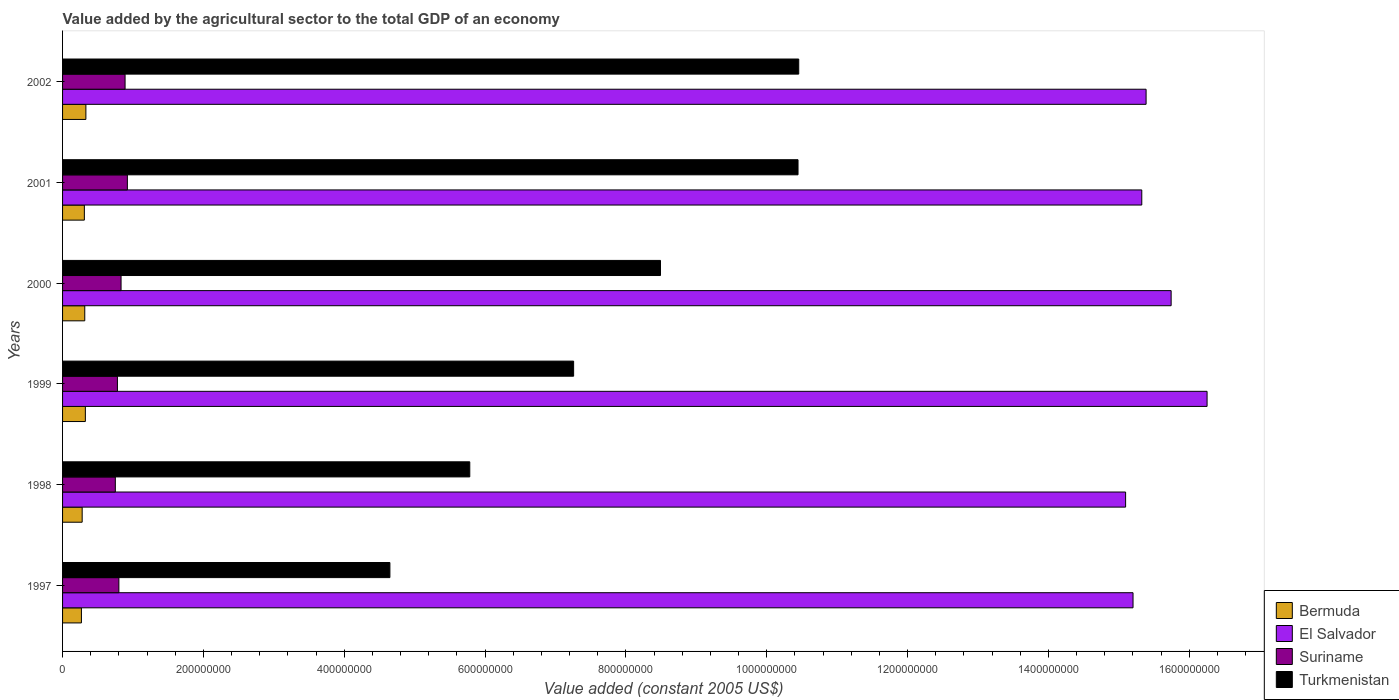How many different coloured bars are there?
Provide a succinct answer. 4. How many groups of bars are there?
Make the answer very short. 6. How many bars are there on the 5th tick from the bottom?
Your answer should be very brief. 4. What is the value added by the agricultural sector in El Salvador in 2001?
Offer a very short reply. 1.53e+09. Across all years, what is the maximum value added by the agricultural sector in El Salvador?
Make the answer very short. 1.63e+09. Across all years, what is the minimum value added by the agricultural sector in El Salvador?
Make the answer very short. 1.51e+09. In which year was the value added by the agricultural sector in Suriname minimum?
Offer a very short reply. 1998. What is the total value added by the agricultural sector in Bermuda in the graph?
Give a very brief answer. 1.83e+08. What is the difference between the value added by the agricultural sector in El Salvador in 1997 and that in 2001?
Give a very brief answer. -1.24e+07. What is the difference between the value added by the agricultural sector in Bermuda in 1997 and the value added by the agricultural sector in Turkmenistan in 2002?
Provide a short and direct response. -1.02e+09. What is the average value added by the agricultural sector in Turkmenistan per year?
Make the answer very short. 7.85e+08. In the year 1999, what is the difference between the value added by the agricultural sector in Suriname and value added by the agricultural sector in Turkmenistan?
Provide a succinct answer. -6.48e+08. In how many years, is the value added by the agricultural sector in Bermuda greater than 40000000 US$?
Your answer should be very brief. 0. What is the ratio of the value added by the agricultural sector in El Salvador in 1997 to that in 2002?
Keep it short and to the point. 0.99. Is the value added by the agricultural sector in Turkmenistan in 1997 less than that in 2000?
Make the answer very short. Yes. Is the difference between the value added by the agricultural sector in Suriname in 1997 and 1998 greater than the difference between the value added by the agricultural sector in Turkmenistan in 1997 and 1998?
Make the answer very short. Yes. What is the difference between the highest and the second highest value added by the agricultural sector in Bermuda?
Provide a short and direct response. 7.62e+05. What is the difference between the highest and the lowest value added by the agricultural sector in Bermuda?
Offer a terse response. 6.35e+06. What does the 4th bar from the top in 2001 represents?
Provide a succinct answer. Bermuda. What does the 2nd bar from the bottom in 2001 represents?
Offer a terse response. El Salvador. How many years are there in the graph?
Your answer should be very brief. 6. What is the difference between two consecutive major ticks on the X-axis?
Ensure brevity in your answer.  2.00e+08. Are the values on the major ticks of X-axis written in scientific E-notation?
Your response must be concise. No. Does the graph contain grids?
Ensure brevity in your answer.  No. How many legend labels are there?
Make the answer very short. 4. How are the legend labels stacked?
Give a very brief answer. Vertical. What is the title of the graph?
Give a very brief answer. Value added by the agricultural sector to the total GDP of an economy. What is the label or title of the X-axis?
Give a very brief answer. Value added (constant 2005 US$). What is the label or title of the Y-axis?
Give a very brief answer. Years. What is the Value added (constant 2005 US$) in Bermuda in 1997?
Your answer should be very brief. 2.68e+07. What is the Value added (constant 2005 US$) in El Salvador in 1997?
Provide a short and direct response. 1.52e+09. What is the Value added (constant 2005 US$) in Suriname in 1997?
Your answer should be compact. 8.00e+07. What is the Value added (constant 2005 US$) in Turkmenistan in 1997?
Provide a succinct answer. 4.65e+08. What is the Value added (constant 2005 US$) of Bermuda in 1998?
Ensure brevity in your answer.  2.78e+07. What is the Value added (constant 2005 US$) in El Salvador in 1998?
Your response must be concise. 1.51e+09. What is the Value added (constant 2005 US$) of Suriname in 1998?
Your answer should be compact. 7.49e+07. What is the Value added (constant 2005 US$) of Turkmenistan in 1998?
Keep it short and to the point. 5.78e+08. What is the Value added (constant 2005 US$) of Bermuda in 1999?
Give a very brief answer. 3.24e+07. What is the Value added (constant 2005 US$) in El Salvador in 1999?
Provide a short and direct response. 1.63e+09. What is the Value added (constant 2005 US$) in Suriname in 1999?
Ensure brevity in your answer.  7.79e+07. What is the Value added (constant 2005 US$) in Turkmenistan in 1999?
Provide a short and direct response. 7.26e+08. What is the Value added (constant 2005 US$) of Bermuda in 2000?
Your answer should be compact. 3.15e+07. What is the Value added (constant 2005 US$) of El Salvador in 2000?
Offer a very short reply. 1.57e+09. What is the Value added (constant 2005 US$) of Suriname in 2000?
Your answer should be very brief. 8.31e+07. What is the Value added (constant 2005 US$) of Turkmenistan in 2000?
Ensure brevity in your answer.  8.49e+08. What is the Value added (constant 2005 US$) in Bermuda in 2001?
Give a very brief answer. 3.10e+07. What is the Value added (constant 2005 US$) in El Salvador in 2001?
Provide a succinct answer. 1.53e+09. What is the Value added (constant 2005 US$) in Suriname in 2001?
Offer a very short reply. 9.20e+07. What is the Value added (constant 2005 US$) of Turkmenistan in 2001?
Your answer should be compact. 1.04e+09. What is the Value added (constant 2005 US$) of Bermuda in 2002?
Ensure brevity in your answer.  3.31e+07. What is the Value added (constant 2005 US$) of El Salvador in 2002?
Offer a terse response. 1.54e+09. What is the Value added (constant 2005 US$) of Suriname in 2002?
Your answer should be very brief. 8.88e+07. What is the Value added (constant 2005 US$) of Turkmenistan in 2002?
Offer a terse response. 1.05e+09. Across all years, what is the maximum Value added (constant 2005 US$) in Bermuda?
Keep it short and to the point. 3.31e+07. Across all years, what is the maximum Value added (constant 2005 US$) in El Salvador?
Your answer should be compact. 1.63e+09. Across all years, what is the maximum Value added (constant 2005 US$) of Suriname?
Your answer should be compact. 9.20e+07. Across all years, what is the maximum Value added (constant 2005 US$) in Turkmenistan?
Your answer should be very brief. 1.05e+09. Across all years, what is the minimum Value added (constant 2005 US$) of Bermuda?
Keep it short and to the point. 2.68e+07. Across all years, what is the minimum Value added (constant 2005 US$) in El Salvador?
Give a very brief answer. 1.51e+09. Across all years, what is the minimum Value added (constant 2005 US$) in Suriname?
Your answer should be compact. 7.49e+07. Across all years, what is the minimum Value added (constant 2005 US$) of Turkmenistan?
Offer a very short reply. 4.65e+08. What is the total Value added (constant 2005 US$) of Bermuda in the graph?
Keep it short and to the point. 1.83e+08. What is the total Value added (constant 2005 US$) in El Salvador in the graph?
Provide a short and direct response. 9.30e+09. What is the total Value added (constant 2005 US$) in Suriname in the graph?
Provide a short and direct response. 4.97e+08. What is the total Value added (constant 2005 US$) in Turkmenistan in the graph?
Your response must be concise. 4.71e+09. What is the difference between the Value added (constant 2005 US$) in Bermuda in 1997 and that in 1998?
Give a very brief answer. -1.04e+06. What is the difference between the Value added (constant 2005 US$) in El Salvador in 1997 and that in 1998?
Make the answer very short. 1.05e+07. What is the difference between the Value added (constant 2005 US$) in Suriname in 1997 and that in 1998?
Provide a succinct answer. 5.05e+06. What is the difference between the Value added (constant 2005 US$) of Turkmenistan in 1997 and that in 1998?
Give a very brief answer. -1.13e+08. What is the difference between the Value added (constant 2005 US$) in Bermuda in 1997 and that in 1999?
Make the answer very short. -5.58e+06. What is the difference between the Value added (constant 2005 US$) in El Salvador in 1997 and that in 1999?
Your response must be concise. -1.05e+08. What is the difference between the Value added (constant 2005 US$) of Suriname in 1997 and that in 1999?
Your response must be concise. 2.06e+06. What is the difference between the Value added (constant 2005 US$) in Turkmenistan in 1997 and that in 1999?
Your answer should be very brief. -2.61e+08. What is the difference between the Value added (constant 2005 US$) in Bermuda in 1997 and that in 2000?
Make the answer very short. -4.74e+06. What is the difference between the Value added (constant 2005 US$) of El Salvador in 1997 and that in 2000?
Provide a succinct answer. -5.41e+07. What is the difference between the Value added (constant 2005 US$) in Suriname in 1997 and that in 2000?
Your response must be concise. -3.09e+06. What is the difference between the Value added (constant 2005 US$) of Turkmenistan in 1997 and that in 2000?
Provide a succinct answer. -3.84e+08. What is the difference between the Value added (constant 2005 US$) of Bermuda in 1997 and that in 2001?
Offer a very short reply. -4.17e+06. What is the difference between the Value added (constant 2005 US$) of El Salvador in 1997 and that in 2001?
Your answer should be compact. -1.24e+07. What is the difference between the Value added (constant 2005 US$) of Suriname in 1997 and that in 2001?
Your answer should be compact. -1.21e+07. What is the difference between the Value added (constant 2005 US$) in Turkmenistan in 1997 and that in 2001?
Give a very brief answer. -5.80e+08. What is the difference between the Value added (constant 2005 US$) in Bermuda in 1997 and that in 2002?
Your answer should be very brief. -6.35e+06. What is the difference between the Value added (constant 2005 US$) in El Salvador in 1997 and that in 2002?
Provide a succinct answer. -1.85e+07. What is the difference between the Value added (constant 2005 US$) of Suriname in 1997 and that in 2002?
Give a very brief answer. -8.80e+06. What is the difference between the Value added (constant 2005 US$) of Turkmenistan in 1997 and that in 2002?
Make the answer very short. -5.81e+08. What is the difference between the Value added (constant 2005 US$) of Bermuda in 1998 and that in 1999?
Your answer should be compact. -4.54e+06. What is the difference between the Value added (constant 2005 US$) in El Salvador in 1998 and that in 1999?
Keep it short and to the point. -1.16e+08. What is the difference between the Value added (constant 2005 US$) in Suriname in 1998 and that in 1999?
Keep it short and to the point. -2.99e+06. What is the difference between the Value added (constant 2005 US$) in Turkmenistan in 1998 and that in 1999?
Provide a short and direct response. -1.47e+08. What is the difference between the Value added (constant 2005 US$) of Bermuda in 1998 and that in 2000?
Provide a short and direct response. -3.70e+06. What is the difference between the Value added (constant 2005 US$) in El Salvador in 1998 and that in 2000?
Keep it short and to the point. -6.47e+07. What is the difference between the Value added (constant 2005 US$) of Suriname in 1998 and that in 2000?
Offer a terse response. -8.14e+06. What is the difference between the Value added (constant 2005 US$) of Turkmenistan in 1998 and that in 2000?
Provide a succinct answer. -2.71e+08. What is the difference between the Value added (constant 2005 US$) of Bermuda in 1998 and that in 2001?
Make the answer very short. -3.12e+06. What is the difference between the Value added (constant 2005 US$) in El Salvador in 1998 and that in 2001?
Your response must be concise. -2.30e+07. What is the difference between the Value added (constant 2005 US$) of Suriname in 1998 and that in 2001?
Offer a terse response. -1.71e+07. What is the difference between the Value added (constant 2005 US$) in Turkmenistan in 1998 and that in 2001?
Your answer should be very brief. -4.66e+08. What is the difference between the Value added (constant 2005 US$) of Bermuda in 1998 and that in 2002?
Give a very brief answer. -5.30e+06. What is the difference between the Value added (constant 2005 US$) of El Salvador in 1998 and that in 2002?
Give a very brief answer. -2.91e+07. What is the difference between the Value added (constant 2005 US$) in Suriname in 1998 and that in 2002?
Make the answer very short. -1.38e+07. What is the difference between the Value added (constant 2005 US$) in Turkmenistan in 1998 and that in 2002?
Your answer should be very brief. -4.67e+08. What is the difference between the Value added (constant 2005 US$) of Bermuda in 1999 and that in 2000?
Your answer should be compact. 8.38e+05. What is the difference between the Value added (constant 2005 US$) of El Salvador in 1999 and that in 2000?
Keep it short and to the point. 5.10e+07. What is the difference between the Value added (constant 2005 US$) of Suriname in 1999 and that in 2000?
Provide a succinct answer. -5.16e+06. What is the difference between the Value added (constant 2005 US$) in Turkmenistan in 1999 and that in 2000?
Provide a short and direct response. -1.23e+08. What is the difference between the Value added (constant 2005 US$) of Bermuda in 1999 and that in 2001?
Make the answer very short. 1.42e+06. What is the difference between the Value added (constant 2005 US$) in El Salvador in 1999 and that in 2001?
Your response must be concise. 9.27e+07. What is the difference between the Value added (constant 2005 US$) in Suriname in 1999 and that in 2001?
Your response must be concise. -1.41e+07. What is the difference between the Value added (constant 2005 US$) of Turkmenistan in 1999 and that in 2001?
Provide a short and direct response. -3.19e+08. What is the difference between the Value added (constant 2005 US$) of Bermuda in 1999 and that in 2002?
Provide a short and direct response. -7.62e+05. What is the difference between the Value added (constant 2005 US$) of El Salvador in 1999 and that in 2002?
Make the answer very short. 8.66e+07. What is the difference between the Value added (constant 2005 US$) in Suriname in 1999 and that in 2002?
Offer a very short reply. -1.09e+07. What is the difference between the Value added (constant 2005 US$) of Turkmenistan in 1999 and that in 2002?
Offer a very short reply. -3.20e+08. What is the difference between the Value added (constant 2005 US$) in Bermuda in 2000 and that in 2001?
Give a very brief answer. 5.77e+05. What is the difference between the Value added (constant 2005 US$) of El Salvador in 2000 and that in 2001?
Your answer should be very brief. 4.17e+07. What is the difference between the Value added (constant 2005 US$) in Suriname in 2000 and that in 2001?
Make the answer very short. -8.96e+06. What is the difference between the Value added (constant 2005 US$) of Turkmenistan in 2000 and that in 2001?
Keep it short and to the point. -1.95e+08. What is the difference between the Value added (constant 2005 US$) of Bermuda in 2000 and that in 2002?
Offer a very short reply. -1.60e+06. What is the difference between the Value added (constant 2005 US$) in El Salvador in 2000 and that in 2002?
Provide a succinct answer. 3.56e+07. What is the difference between the Value added (constant 2005 US$) in Suriname in 2000 and that in 2002?
Provide a succinct answer. -5.70e+06. What is the difference between the Value added (constant 2005 US$) of Turkmenistan in 2000 and that in 2002?
Your response must be concise. -1.96e+08. What is the difference between the Value added (constant 2005 US$) in Bermuda in 2001 and that in 2002?
Provide a succinct answer. -2.18e+06. What is the difference between the Value added (constant 2005 US$) of El Salvador in 2001 and that in 2002?
Your answer should be very brief. -6.12e+06. What is the difference between the Value added (constant 2005 US$) of Suriname in 2001 and that in 2002?
Your response must be concise. 3.26e+06. What is the difference between the Value added (constant 2005 US$) in Turkmenistan in 2001 and that in 2002?
Provide a short and direct response. -9.92e+05. What is the difference between the Value added (constant 2005 US$) of Bermuda in 1997 and the Value added (constant 2005 US$) of El Salvador in 1998?
Your answer should be very brief. -1.48e+09. What is the difference between the Value added (constant 2005 US$) in Bermuda in 1997 and the Value added (constant 2005 US$) in Suriname in 1998?
Your response must be concise. -4.81e+07. What is the difference between the Value added (constant 2005 US$) in Bermuda in 1997 and the Value added (constant 2005 US$) in Turkmenistan in 1998?
Ensure brevity in your answer.  -5.51e+08. What is the difference between the Value added (constant 2005 US$) of El Salvador in 1997 and the Value added (constant 2005 US$) of Suriname in 1998?
Keep it short and to the point. 1.45e+09. What is the difference between the Value added (constant 2005 US$) in El Salvador in 1997 and the Value added (constant 2005 US$) in Turkmenistan in 1998?
Offer a terse response. 9.42e+08. What is the difference between the Value added (constant 2005 US$) of Suriname in 1997 and the Value added (constant 2005 US$) of Turkmenistan in 1998?
Ensure brevity in your answer.  -4.98e+08. What is the difference between the Value added (constant 2005 US$) of Bermuda in 1997 and the Value added (constant 2005 US$) of El Salvador in 1999?
Your answer should be compact. -1.60e+09. What is the difference between the Value added (constant 2005 US$) of Bermuda in 1997 and the Value added (constant 2005 US$) of Suriname in 1999?
Provide a succinct answer. -5.11e+07. What is the difference between the Value added (constant 2005 US$) in Bermuda in 1997 and the Value added (constant 2005 US$) in Turkmenistan in 1999?
Offer a terse response. -6.99e+08. What is the difference between the Value added (constant 2005 US$) of El Salvador in 1997 and the Value added (constant 2005 US$) of Suriname in 1999?
Provide a succinct answer. 1.44e+09. What is the difference between the Value added (constant 2005 US$) of El Salvador in 1997 and the Value added (constant 2005 US$) of Turkmenistan in 1999?
Offer a terse response. 7.94e+08. What is the difference between the Value added (constant 2005 US$) of Suriname in 1997 and the Value added (constant 2005 US$) of Turkmenistan in 1999?
Your answer should be very brief. -6.46e+08. What is the difference between the Value added (constant 2005 US$) in Bermuda in 1997 and the Value added (constant 2005 US$) in El Salvador in 2000?
Make the answer very short. -1.55e+09. What is the difference between the Value added (constant 2005 US$) in Bermuda in 1997 and the Value added (constant 2005 US$) in Suriname in 2000?
Give a very brief answer. -5.63e+07. What is the difference between the Value added (constant 2005 US$) of Bermuda in 1997 and the Value added (constant 2005 US$) of Turkmenistan in 2000?
Keep it short and to the point. -8.22e+08. What is the difference between the Value added (constant 2005 US$) in El Salvador in 1997 and the Value added (constant 2005 US$) in Suriname in 2000?
Make the answer very short. 1.44e+09. What is the difference between the Value added (constant 2005 US$) in El Salvador in 1997 and the Value added (constant 2005 US$) in Turkmenistan in 2000?
Keep it short and to the point. 6.71e+08. What is the difference between the Value added (constant 2005 US$) of Suriname in 1997 and the Value added (constant 2005 US$) of Turkmenistan in 2000?
Provide a short and direct response. -7.69e+08. What is the difference between the Value added (constant 2005 US$) in Bermuda in 1997 and the Value added (constant 2005 US$) in El Salvador in 2001?
Give a very brief answer. -1.51e+09. What is the difference between the Value added (constant 2005 US$) of Bermuda in 1997 and the Value added (constant 2005 US$) of Suriname in 2001?
Offer a very short reply. -6.52e+07. What is the difference between the Value added (constant 2005 US$) in Bermuda in 1997 and the Value added (constant 2005 US$) in Turkmenistan in 2001?
Your response must be concise. -1.02e+09. What is the difference between the Value added (constant 2005 US$) in El Salvador in 1997 and the Value added (constant 2005 US$) in Suriname in 2001?
Your answer should be very brief. 1.43e+09. What is the difference between the Value added (constant 2005 US$) in El Salvador in 1997 and the Value added (constant 2005 US$) in Turkmenistan in 2001?
Give a very brief answer. 4.76e+08. What is the difference between the Value added (constant 2005 US$) of Suriname in 1997 and the Value added (constant 2005 US$) of Turkmenistan in 2001?
Your answer should be very brief. -9.64e+08. What is the difference between the Value added (constant 2005 US$) of Bermuda in 1997 and the Value added (constant 2005 US$) of El Salvador in 2002?
Ensure brevity in your answer.  -1.51e+09. What is the difference between the Value added (constant 2005 US$) in Bermuda in 1997 and the Value added (constant 2005 US$) in Suriname in 2002?
Provide a short and direct response. -6.20e+07. What is the difference between the Value added (constant 2005 US$) in Bermuda in 1997 and the Value added (constant 2005 US$) in Turkmenistan in 2002?
Provide a short and direct response. -1.02e+09. What is the difference between the Value added (constant 2005 US$) in El Salvador in 1997 and the Value added (constant 2005 US$) in Suriname in 2002?
Provide a short and direct response. 1.43e+09. What is the difference between the Value added (constant 2005 US$) in El Salvador in 1997 and the Value added (constant 2005 US$) in Turkmenistan in 2002?
Offer a terse response. 4.75e+08. What is the difference between the Value added (constant 2005 US$) in Suriname in 1997 and the Value added (constant 2005 US$) in Turkmenistan in 2002?
Make the answer very short. -9.65e+08. What is the difference between the Value added (constant 2005 US$) of Bermuda in 1998 and the Value added (constant 2005 US$) of El Salvador in 1999?
Offer a very short reply. -1.60e+09. What is the difference between the Value added (constant 2005 US$) in Bermuda in 1998 and the Value added (constant 2005 US$) in Suriname in 1999?
Offer a very short reply. -5.01e+07. What is the difference between the Value added (constant 2005 US$) in Bermuda in 1998 and the Value added (constant 2005 US$) in Turkmenistan in 1999?
Provide a short and direct response. -6.98e+08. What is the difference between the Value added (constant 2005 US$) of El Salvador in 1998 and the Value added (constant 2005 US$) of Suriname in 1999?
Offer a terse response. 1.43e+09. What is the difference between the Value added (constant 2005 US$) of El Salvador in 1998 and the Value added (constant 2005 US$) of Turkmenistan in 1999?
Give a very brief answer. 7.84e+08. What is the difference between the Value added (constant 2005 US$) of Suriname in 1998 and the Value added (constant 2005 US$) of Turkmenistan in 1999?
Your response must be concise. -6.51e+08. What is the difference between the Value added (constant 2005 US$) in Bermuda in 1998 and the Value added (constant 2005 US$) in El Salvador in 2000?
Offer a terse response. -1.55e+09. What is the difference between the Value added (constant 2005 US$) of Bermuda in 1998 and the Value added (constant 2005 US$) of Suriname in 2000?
Give a very brief answer. -5.52e+07. What is the difference between the Value added (constant 2005 US$) of Bermuda in 1998 and the Value added (constant 2005 US$) of Turkmenistan in 2000?
Offer a terse response. -8.21e+08. What is the difference between the Value added (constant 2005 US$) of El Salvador in 1998 and the Value added (constant 2005 US$) of Suriname in 2000?
Your response must be concise. 1.43e+09. What is the difference between the Value added (constant 2005 US$) in El Salvador in 1998 and the Value added (constant 2005 US$) in Turkmenistan in 2000?
Give a very brief answer. 6.60e+08. What is the difference between the Value added (constant 2005 US$) of Suriname in 1998 and the Value added (constant 2005 US$) of Turkmenistan in 2000?
Your response must be concise. -7.74e+08. What is the difference between the Value added (constant 2005 US$) in Bermuda in 1998 and the Value added (constant 2005 US$) in El Salvador in 2001?
Your answer should be compact. -1.50e+09. What is the difference between the Value added (constant 2005 US$) of Bermuda in 1998 and the Value added (constant 2005 US$) of Suriname in 2001?
Ensure brevity in your answer.  -6.42e+07. What is the difference between the Value added (constant 2005 US$) of Bermuda in 1998 and the Value added (constant 2005 US$) of Turkmenistan in 2001?
Your response must be concise. -1.02e+09. What is the difference between the Value added (constant 2005 US$) in El Salvador in 1998 and the Value added (constant 2005 US$) in Suriname in 2001?
Ensure brevity in your answer.  1.42e+09. What is the difference between the Value added (constant 2005 US$) of El Salvador in 1998 and the Value added (constant 2005 US$) of Turkmenistan in 2001?
Ensure brevity in your answer.  4.65e+08. What is the difference between the Value added (constant 2005 US$) in Suriname in 1998 and the Value added (constant 2005 US$) in Turkmenistan in 2001?
Ensure brevity in your answer.  -9.69e+08. What is the difference between the Value added (constant 2005 US$) in Bermuda in 1998 and the Value added (constant 2005 US$) in El Salvador in 2002?
Make the answer very short. -1.51e+09. What is the difference between the Value added (constant 2005 US$) in Bermuda in 1998 and the Value added (constant 2005 US$) in Suriname in 2002?
Your answer should be very brief. -6.09e+07. What is the difference between the Value added (constant 2005 US$) in Bermuda in 1998 and the Value added (constant 2005 US$) in Turkmenistan in 2002?
Give a very brief answer. -1.02e+09. What is the difference between the Value added (constant 2005 US$) of El Salvador in 1998 and the Value added (constant 2005 US$) of Suriname in 2002?
Make the answer very short. 1.42e+09. What is the difference between the Value added (constant 2005 US$) in El Salvador in 1998 and the Value added (constant 2005 US$) in Turkmenistan in 2002?
Give a very brief answer. 4.64e+08. What is the difference between the Value added (constant 2005 US$) of Suriname in 1998 and the Value added (constant 2005 US$) of Turkmenistan in 2002?
Offer a terse response. -9.70e+08. What is the difference between the Value added (constant 2005 US$) of Bermuda in 1999 and the Value added (constant 2005 US$) of El Salvador in 2000?
Keep it short and to the point. -1.54e+09. What is the difference between the Value added (constant 2005 US$) of Bermuda in 1999 and the Value added (constant 2005 US$) of Suriname in 2000?
Your answer should be very brief. -5.07e+07. What is the difference between the Value added (constant 2005 US$) in Bermuda in 1999 and the Value added (constant 2005 US$) in Turkmenistan in 2000?
Keep it short and to the point. -8.17e+08. What is the difference between the Value added (constant 2005 US$) in El Salvador in 1999 and the Value added (constant 2005 US$) in Suriname in 2000?
Offer a very short reply. 1.54e+09. What is the difference between the Value added (constant 2005 US$) in El Salvador in 1999 and the Value added (constant 2005 US$) in Turkmenistan in 2000?
Make the answer very short. 7.76e+08. What is the difference between the Value added (constant 2005 US$) in Suriname in 1999 and the Value added (constant 2005 US$) in Turkmenistan in 2000?
Make the answer very short. -7.71e+08. What is the difference between the Value added (constant 2005 US$) of Bermuda in 1999 and the Value added (constant 2005 US$) of El Salvador in 2001?
Provide a short and direct response. -1.50e+09. What is the difference between the Value added (constant 2005 US$) of Bermuda in 1999 and the Value added (constant 2005 US$) of Suriname in 2001?
Your answer should be compact. -5.97e+07. What is the difference between the Value added (constant 2005 US$) in Bermuda in 1999 and the Value added (constant 2005 US$) in Turkmenistan in 2001?
Your response must be concise. -1.01e+09. What is the difference between the Value added (constant 2005 US$) of El Salvador in 1999 and the Value added (constant 2005 US$) of Suriname in 2001?
Keep it short and to the point. 1.53e+09. What is the difference between the Value added (constant 2005 US$) in El Salvador in 1999 and the Value added (constant 2005 US$) in Turkmenistan in 2001?
Make the answer very short. 5.81e+08. What is the difference between the Value added (constant 2005 US$) of Suriname in 1999 and the Value added (constant 2005 US$) of Turkmenistan in 2001?
Offer a very short reply. -9.66e+08. What is the difference between the Value added (constant 2005 US$) of Bermuda in 1999 and the Value added (constant 2005 US$) of El Salvador in 2002?
Provide a succinct answer. -1.51e+09. What is the difference between the Value added (constant 2005 US$) of Bermuda in 1999 and the Value added (constant 2005 US$) of Suriname in 2002?
Your answer should be compact. -5.64e+07. What is the difference between the Value added (constant 2005 US$) of Bermuda in 1999 and the Value added (constant 2005 US$) of Turkmenistan in 2002?
Give a very brief answer. -1.01e+09. What is the difference between the Value added (constant 2005 US$) in El Salvador in 1999 and the Value added (constant 2005 US$) in Suriname in 2002?
Provide a short and direct response. 1.54e+09. What is the difference between the Value added (constant 2005 US$) in El Salvador in 1999 and the Value added (constant 2005 US$) in Turkmenistan in 2002?
Ensure brevity in your answer.  5.80e+08. What is the difference between the Value added (constant 2005 US$) of Suriname in 1999 and the Value added (constant 2005 US$) of Turkmenistan in 2002?
Make the answer very short. -9.67e+08. What is the difference between the Value added (constant 2005 US$) in Bermuda in 2000 and the Value added (constant 2005 US$) in El Salvador in 2001?
Your answer should be compact. -1.50e+09. What is the difference between the Value added (constant 2005 US$) in Bermuda in 2000 and the Value added (constant 2005 US$) in Suriname in 2001?
Offer a terse response. -6.05e+07. What is the difference between the Value added (constant 2005 US$) in Bermuda in 2000 and the Value added (constant 2005 US$) in Turkmenistan in 2001?
Provide a succinct answer. -1.01e+09. What is the difference between the Value added (constant 2005 US$) in El Salvador in 2000 and the Value added (constant 2005 US$) in Suriname in 2001?
Your answer should be very brief. 1.48e+09. What is the difference between the Value added (constant 2005 US$) in El Salvador in 2000 and the Value added (constant 2005 US$) in Turkmenistan in 2001?
Ensure brevity in your answer.  5.30e+08. What is the difference between the Value added (constant 2005 US$) of Suriname in 2000 and the Value added (constant 2005 US$) of Turkmenistan in 2001?
Make the answer very short. -9.61e+08. What is the difference between the Value added (constant 2005 US$) in Bermuda in 2000 and the Value added (constant 2005 US$) in El Salvador in 2002?
Offer a very short reply. -1.51e+09. What is the difference between the Value added (constant 2005 US$) of Bermuda in 2000 and the Value added (constant 2005 US$) of Suriname in 2002?
Provide a succinct answer. -5.72e+07. What is the difference between the Value added (constant 2005 US$) in Bermuda in 2000 and the Value added (constant 2005 US$) in Turkmenistan in 2002?
Your answer should be very brief. -1.01e+09. What is the difference between the Value added (constant 2005 US$) of El Salvador in 2000 and the Value added (constant 2005 US$) of Suriname in 2002?
Keep it short and to the point. 1.49e+09. What is the difference between the Value added (constant 2005 US$) in El Salvador in 2000 and the Value added (constant 2005 US$) in Turkmenistan in 2002?
Your answer should be very brief. 5.29e+08. What is the difference between the Value added (constant 2005 US$) in Suriname in 2000 and the Value added (constant 2005 US$) in Turkmenistan in 2002?
Make the answer very short. -9.62e+08. What is the difference between the Value added (constant 2005 US$) of Bermuda in 2001 and the Value added (constant 2005 US$) of El Salvador in 2002?
Your answer should be very brief. -1.51e+09. What is the difference between the Value added (constant 2005 US$) in Bermuda in 2001 and the Value added (constant 2005 US$) in Suriname in 2002?
Give a very brief answer. -5.78e+07. What is the difference between the Value added (constant 2005 US$) in Bermuda in 2001 and the Value added (constant 2005 US$) in Turkmenistan in 2002?
Give a very brief answer. -1.01e+09. What is the difference between the Value added (constant 2005 US$) in El Salvador in 2001 and the Value added (constant 2005 US$) in Suriname in 2002?
Make the answer very short. 1.44e+09. What is the difference between the Value added (constant 2005 US$) in El Salvador in 2001 and the Value added (constant 2005 US$) in Turkmenistan in 2002?
Offer a very short reply. 4.87e+08. What is the difference between the Value added (constant 2005 US$) of Suriname in 2001 and the Value added (constant 2005 US$) of Turkmenistan in 2002?
Offer a terse response. -9.53e+08. What is the average Value added (constant 2005 US$) of Bermuda per year?
Offer a very short reply. 3.04e+07. What is the average Value added (constant 2005 US$) of El Salvador per year?
Offer a very short reply. 1.55e+09. What is the average Value added (constant 2005 US$) in Suriname per year?
Provide a short and direct response. 8.28e+07. What is the average Value added (constant 2005 US$) in Turkmenistan per year?
Provide a short and direct response. 7.85e+08. In the year 1997, what is the difference between the Value added (constant 2005 US$) of Bermuda and Value added (constant 2005 US$) of El Salvador?
Provide a short and direct response. -1.49e+09. In the year 1997, what is the difference between the Value added (constant 2005 US$) in Bermuda and Value added (constant 2005 US$) in Suriname?
Provide a short and direct response. -5.32e+07. In the year 1997, what is the difference between the Value added (constant 2005 US$) of Bermuda and Value added (constant 2005 US$) of Turkmenistan?
Your answer should be very brief. -4.38e+08. In the year 1997, what is the difference between the Value added (constant 2005 US$) in El Salvador and Value added (constant 2005 US$) in Suriname?
Your answer should be very brief. 1.44e+09. In the year 1997, what is the difference between the Value added (constant 2005 US$) in El Salvador and Value added (constant 2005 US$) in Turkmenistan?
Keep it short and to the point. 1.06e+09. In the year 1997, what is the difference between the Value added (constant 2005 US$) in Suriname and Value added (constant 2005 US$) in Turkmenistan?
Your response must be concise. -3.85e+08. In the year 1998, what is the difference between the Value added (constant 2005 US$) in Bermuda and Value added (constant 2005 US$) in El Salvador?
Offer a very short reply. -1.48e+09. In the year 1998, what is the difference between the Value added (constant 2005 US$) in Bermuda and Value added (constant 2005 US$) in Suriname?
Keep it short and to the point. -4.71e+07. In the year 1998, what is the difference between the Value added (constant 2005 US$) of Bermuda and Value added (constant 2005 US$) of Turkmenistan?
Provide a succinct answer. -5.50e+08. In the year 1998, what is the difference between the Value added (constant 2005 US$) in El Salvador and Value added (constant 2005 US$) in Suriname?
Keep it short and to the point. 1.43e+09. In the year 1998, what is the difference between the Value added (constant 2005 US$) of El Salvador and Value added (constant 2005 US$) of Turkmenistan?
Your answer should be compact. 9.31e+08. In the year 1998, what is the difference between the Value added (constant 2005 US$) in Suriname and Value added (constant 2005 US$) in Turkmenistan?
Give a very brief answer. -5.03e+08. In the year 1999, what is the difference between the Value added (constant 2005 US$) of Bermuda and Value added (constant 2005 US$) of El Salvador?
Your answer should be compact. -1.59e+09. In the year 1999, what is the difference between the Value added (constant 2005 US$) in Bermuda and Value added (constant 2005 US$) in Suriname?
Your answer should be very brief. -4.55e+07. In the year 1999, what is the difference between the Value added (constant 2005 US$) of Bermuda and Value added (constant 2005 US$) of Turkmenistan?
Provide a short and direct response. -6.93e+08. In the year 1999, what is the difference between the Value added (constant 2005 US$) of El Salvador and Value added (constant 2005 US$) of Suriname?
Ensure brevity in your answer.  1.55e+09. In the year 1999, what is the difference between the Value added (constant 2005 US$) of El Salvador and Value added (constant 2005 US$) of Turkmenistan?
Provide a short and direct response. 9.00e+08. In the year 1999, what is the difference between the Value added (constant 2005 US$) in Suriname and Value added (constant 2005 US$) in Turkmenistan?
Provide a succinct answer. -6.48e+08. In the year 2000, what is the difference between the Value added (constant 2005 US$) in Bermuda and Value added (constant 2005 US$) in El Salvador?
Your answer should be compact. -1.54e+09. In the year 2000, what is the difference between the Value added (constant 2005 US$) of Bermuda and Value added (constant 2005 US$) of Suriname?
Give a very brief answer. -5.15e+07. In the year 2000, what is the difference between the Value added (constant 2005 US$) of Bermuda and Value added (constant 2005 US$) of Turkmenistan?
Offer a terse response. -8.18e+08. In the year 2000, what is the difference between the Value added (constant 2005 US$) in El Salvador and Value added (constant 2005 US$) in Suriname?
Make the answer very short. 1.49e+09. In the year 2000, what is the difference between the Value added (constant 2005 US$) of El Salvador and Value added (constant 2005 US$) of Turkmenistan?
Offer a terse response. 7.25e+08. In the year 2000, what is the difference between the Value added (constant 2005 US$) in Suriname and Value added (constant 2005 US$) in Turkmenistan?
Offer a very short reply. -7.66e+08. In the year 2001, what is the difference between the Value added (constant 2005 US$) in Bermuda and Value added (constant 2005 US$) in El Salvador?
Offer a terse response. -1.50e+09. In the year 2001, what is the difference between the Value added (constant 2005 US$) in Bermuda and Value added (constant 2005 US$) in Suriname?
Your answer should be compact. -6.11e+07. In the year 2001, what is the difference between the Value added (constant 2005 US$) in Bermuda and Value added (constant 2005 US$) in Turkmenistan?
Give a very brief answer. -1.01e+09. In the year 2001, what is the difference between the Value added (constant 2005 US$) of El Salvador and Value added (constant 2005 US$) of Suriname?
Your response must be concise. 1.44e+09. In the year 2001, what is the difference between the Value added (constant 2005 US$) of El Salvador and Value added (constant 2005 US$) of Turkmenistan?
Provide a short and direct response. 4.88e+08. In the year 2001, what is the difference between the Value added (constant 2005 US$) of Suriname and Value added (constant 2005 US$) of Turkmenistan?
Offer a very short reply. -9.52e+08. In the year 2002, what is the difference between the Value added (constant 2005 US$) of Bermuda and Value added (constant 2005 US$) of El Salvador?
Your response must be concise. -1.51e+09. In the year 2002, what is the difference between the Value added (constant 2005 US$) of Bermuda and Value added (constant 2005 US$) of Suriname?
Make the answer very short. -5.56e+07. In the year 2002, what is the difference between the Value added (constant 2005 US$) in Bermuda and Value added (constant 2005 US$) in Turkmenistan?
Your answer should be compact. -1.01e+09. In the year 2002, what is the difference between the Value added (constant 2005 US$) of El Salvador and Value added (constant 2005 US$) of Suriname?
Make the answer very short. 1.45e+09. In the year 2002, what is the difference between the Value added (constant 2005 US$) of El Salvador and Value added (constant 2005 US$) of Turkmenistan?
Offer a terse response. 4.93e+08. In the year 2002, what is the difference between the Value added (constant 2005 US$) in Suriname and Value added (constant 2005 US$) in Turkmenistan?
Give a very brief answer. -9.57e+08. What is the ratio of the Value added (constant 2005 US$) in Bermuda in 1997 to that in 1998?
Offer a very short reply. 0.96. What is the ratio of the Value added (constant 2005 US$) in El Salvador in 1997 to that in 1998?
Give a very brief answer. 1.01. What is the ratio of the Value added (constant 2005 US$) in Suriname in 1997 to that in 1998?
Offer a terse response. 1.07. What is the ratio of the Value added (constant 2005 US$) in Turkmenistan in 1997 to that in 1998?
Provide a short and direct response. 0.8. What is the ratio of the Value added (constant 2005 US$) in Bermuda in 1997 to that in 1999?
Give a very brief answer. 0.83. What is the ratio of the Value added (constant 2005 US$) of El Salvador in 1997 to that in 1999?
Your answer should be compact. 0.94. What is the ratio of the Value added (constant 2005 US$) in Suriname in 1997 to that in 1999?
Keep it short and to the point. 1.03. What is the ratio of the Value added (constant 2005 US$) of Turkmenistan in 1997 to that in 1999?
Ensure brevity in your answer.  0.64. What is the ratio of the Value added (constant 2005 US$) of Bermuda in 1997 to that in 2000?
Give a very brief answer. 0.85. What is the ratio of the Value added (constant 2005 US$) in El Salvador in 1997 to that in 2000?
Your answer should be compact. 0.97. What is the ratio of the Value added (constant 2005 US$) in Suriname in 1997 to that in 2000?
Your answer should be very brief. 0.96. What is the ratio of the Value added (constant 2005 US$) of Turkmenistan in 1997 to that in 2000?
Provide a short and direct response. 0.55. What is the ratio of the Value added (constant 2005 US$) in Bermuda in 1997 to that in 2001?
Provide a short and direct response. 0.87. What is the ratio of the Value added (constant 2005 US$) in Suriname in 1997 to that in 2001?
Make the answer very short. 0.87. What is the ratio of the Value added (constant 2005 US$) of Turkmenistan in 1997 to that in 2001?
Give a very brief answer. 0.45. What is the ratio of the Value added (constant 2005 US$) in Bermuda in 1997 to that in 2002?
Provide a short and direct response. 0.81. What is the ratio of the Value added (constant 2005 US$) of El Salvador in 1997 to that in 2002?
Provide a succinct answer. 0.99. What is the ratio of the Value added (constant 2005 US$) of Suriname in 1997 to that in 2002?
Provide a succinct answer. 0.9. What is the ratio of the Value added (constant 2005 US$) in Turkmenistan in 1997 to that in 2002?
Make the answer very short. 0.44. What is the ratio of the Value added (constant 2005 US$) in Bermuda in 1998 to that in 1999?
Give a very brief answer. 0.86. What is the ratio of the Value added (constant 2005 US$) in El Salvador in 1998 to that in 1999?
Offer a very short reply. 0.93. What is the ratio of the Value added (constant 2005 US$) in Suriname in 1998 to that in 1999?
Your answer should be compact. 0.96. What is the ratio of the Value added (constant 2005 US$) of Turkmenistan in 1998 to that in 1999?
Your answer should be compact. 0.8. What is the ratio of the Value added (constant 2005 US$) of Bermuda in 1998 to that in 2000?
Give a very brief answer. 0.88. What is the ratio of the Value added (constant 2005 US$) in El Salvador in 1998 to that in 2000?
Your answer should be compact. 0.96. What is the ratio of the Value added (constant 2005 US$) of Suriname in 1998 to that in 2000?
Provide a succinct answer. 0.9. What is the ratio of the Value added (constant 2005 US$) of Turkmenistan in 1998 to that in 2000?
Provide a short and direct response. 0.68. What is the ratio of the Value added (constant 2005 US$) of Bermuda in 1998 to that in 2001?
Provide a short and direct response. 0.9. What is the ratio of the Value added (constant 2005 US$) in El Salvador in 1998 to that in 2001?
Offer a very short reply. 0.98. What is the ratio of the Value added (constant 2005 US$) in Suriname in 1998 to that in 2001?
Your response must be concise. 0.81. What is the ratio of the Value added (constant 2005 US$) of Turkmenistan in 1998 to that in 2001?
Keep it short and to the point. 0.55. What is the ratio of the Value added (constant 2005 US$) in Bermuda in 1998 to that in 2002?
Provide a short and direct response. 0.84. What is the ratio of the Value added (constant 2005 US$) in El Salvador in 1998 to that in 2002?
Give a very brief answer. 0.98. What is the ratio of the Value added (constant 2005 US$) in Suriname in 1998 to that in 2002?
Make the answer very short. 0.84. What is the ratio of the Value added (constant 2005 US$) in Turkmenistan in 1998 to that in 2002?
Keep it short and to the point. 0.55. What is the ratio of the Value added (constant 2005 US$) of Bermuda in 1999 to that in 2000?
Give a very brief answer. 1.03. What is the ratio of the Value added (constant 2005 US$) of El Salvador in 1999 to that in 2000?
Make the answer very short. 1.03. What is the ratio of the Value added (constant 2005 US$) in Suriname in 1999 to that in 2000?
Make the answer very short. 0.94. What is the ratio of the Value added (constant 2005 US$) in Turkmenistan in 1999 to that in 2000?
Ensure brevity in your answer.  0.85. What is the ratio of the Value added (constant 2005 US$) in Bermuda in 1999 to that in 2001?
Offer a very short reply. 1.05. What is the ratio of the Value added (constant 2005 US$) in El Salvador in 1999 to that in 2001?
Ensure brevity in your answer.  1.06. What is the ratio of the Value added (constant 2005 US$) of Suriname in 1999 to that in 2001?
Provide a succinct answer. 0.85. What is the ratio of the Value added (constant 2005 US$) in Turkmenistan in 1999 to that in 2001?
Ensure brevity in your answer.  0.69. What is the ratio of the Value added (constant 2005 US$) of El Salvador in 1999 to that in 2002?
Ensure brevity in your answer.  1.06. What is the ratio of the Value added (constant 2005 US$) in Suriname in 1999 to that in 2002?
Keep it short and to the point. 0.88. What is the ratio of the Value added (constant 2005 US$) of Turkmenistan in 1999 to that in 2002?
Give a very brief answer. 0.69. What is the ratio of the Value added (constant 2005 US$) in Bermuda in 2000 to that in 2001?
Make the answer very short. 1.02. What is the ratio of the Value added (constant 2005 US$) in El Salvador in 2000 to that in 2001?
Keep it short and to the point. 1.03. What is the ratio of the Value added (constant 2005 US$) in Suriname in 2000 to that in 2001?
Offer a terse response. 0.9. What is the ratio of the Value added (constant 2005 US$) in Turkmenistan in 2000 to that in 2001?
Give a very brief answer. 0.81. What is the ratio of the Value added (constant 2005 US$) in Bermuda in 2000 to that in 2002?
Your response must be concise. 0.95. What is the ratio of the Value added (constant 2005 US$) in El Salvador in 2000 to that in 2002?
Keep it short and to the point. 1.02. What is the ratio of the Value added (constant 2005 US$) in Suriname in 2000 to that in 2002?
Your answer should be very brief. 0.94. What is the ratio of the Value added (constant 2005 US$) of Turkmenistan in 2000 to that in 2002?
Your answer should be very brief. 0.81. What is the ratio of the Value added (constant 2005 US$) in Bermuda in 2001 to that in 2002?
Ensure brevity in your answer.  0.93. What is the ratio of the Value added (constant 2005 US$) in Suriname in 2001 to that in 2002?
Give a very brief answer. 1.04. What is the ratio of the Value added (constant 2005 US$) in Turkmenistan in 2001 to that in 2002?
Your answer should be compact. 1. What is the difference between the highest and the second highest Value added (constant 2005 US$) in Bermuda?
Keep it short and to the point. 7.62e+05. What is the difference between the highest and the second highest Value added (constant 2005 US$) of El Salvador?
Offer a very short reply. 5.10e+07. What is the difference between the highest and the second highest Value added (constant 2005 US$) in Suriname?
Ensure brevity in your answer.  3.26e+06. What is the difference between the highest and the second highest Value added (constant 2005 US$) of Turkmenistan?
Offer a very short reply. 9.92e+05. What is the difference between the highest and the lowest Value added (constant 2005 US$) of Bermuda?
Offer a terse response. 6.35e+06. What is the difference between the highest and the lowest Value added (constant 2005 US$) of El Salvador?
Make the answer very short. 1.16e+08. What is the difference between the highest and the lowest Value added (constant 2005 US$) in Suriname?
Offer a very short reply. 1.71e+07. What is the difference between the highest and the lowest Value added (constant 2005 US$) in Turkmenistan?
Offer a very short reply. 5.81e+08. 